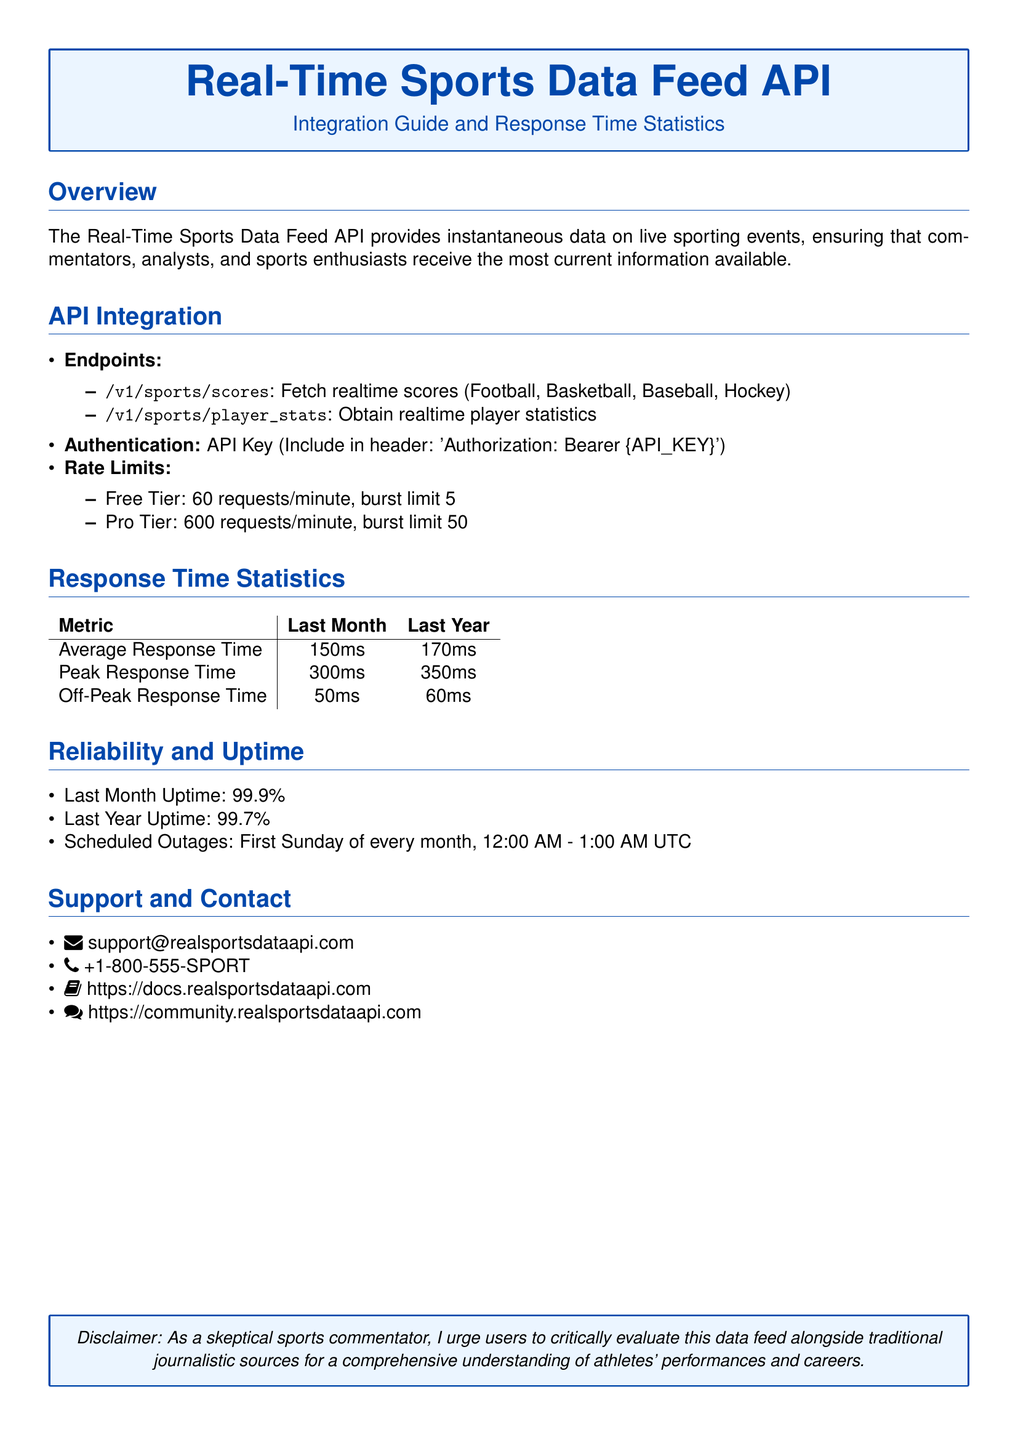What is the API key used for? The API key is used for authentication and must be included in the header of requests.
Answer: Authentication What is the average response time last month? The average response time for the last month is provided in the statistics section.
Answer: 150ms What are the scheduled outage times? The document states that scheduled outages occur on the first Sunday of every month from 12:00 AM to 1:00 AM UTC.
Answer: First Sunday of every month, 12:00 AM - 1:00 AM UTC What is the peak response time last year? The peak response time for the last year is listed in the response time statistics.
Answer: 350ms How many requests are allowed per minute in the Pro Tier? The Pro Tier rate limits specify the maximum number of requests allowed per minute.
Answer: 600 requests/minute What is the last month's uptime percentage? The uptime percentage for the last month is mentioned in the reliability and uptime section.
Answer: 99.9% What types of sports data can you fetch? The document lists the types of sports for which real-time scores can be fetched.
Answer: Football, Basketball, Baseball, Hockey How can users contact support? Multiple contact methods for support are provided, including email and phone.
Answer: support@realsportsdataapi.com What is emphasized in the disclaimer? The disclaimer urges users to critically evaluate the data feed alongside traditional sources.
Answer: Critically evaluate data feed alongside traditional sources 